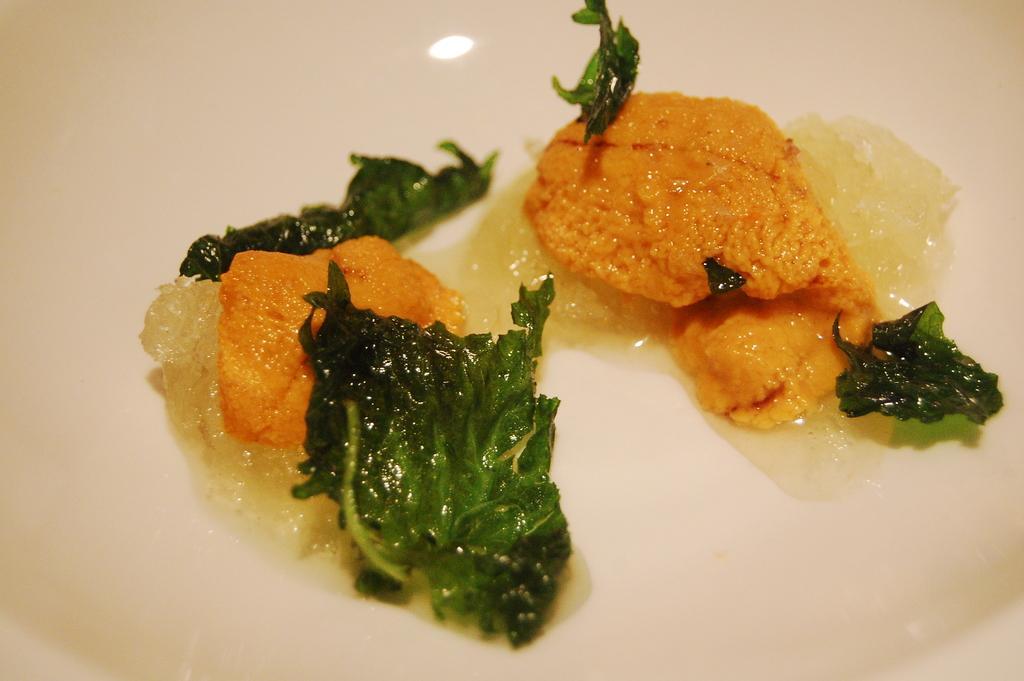In one or two sentences, can you explain what this image depicts? In this image I can see some food item in the plate. 